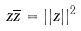<formula> <loc_0><loc_0><loc_500><loc_500>z \overline { z } = | | z | | ^ { 2 }</formula> 